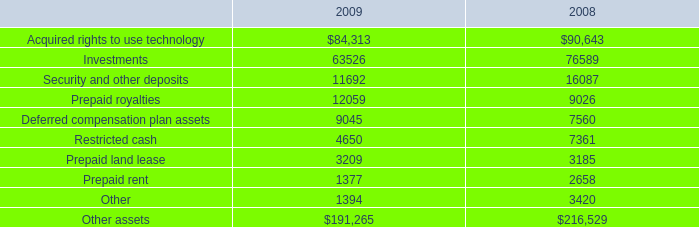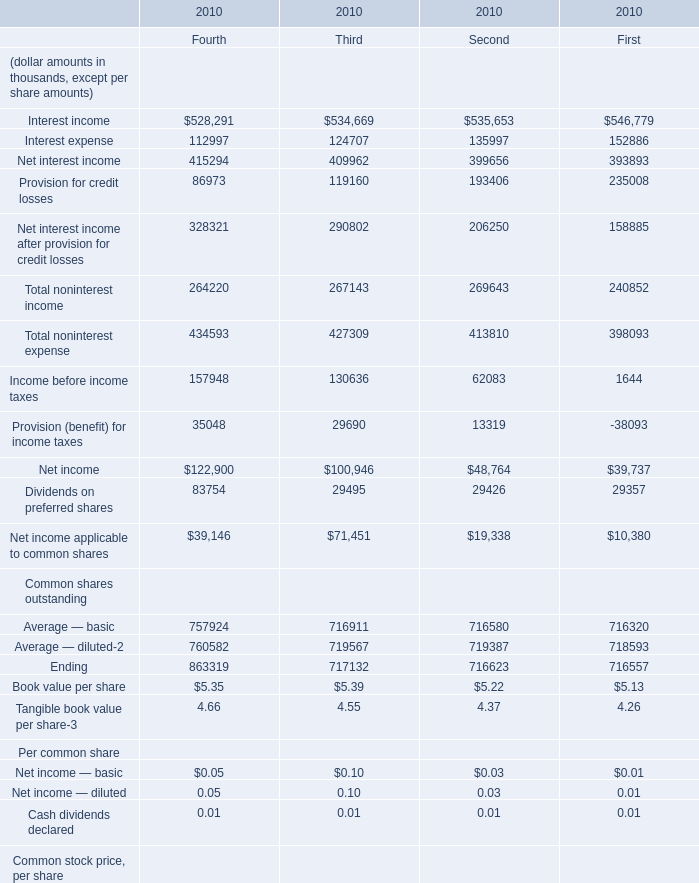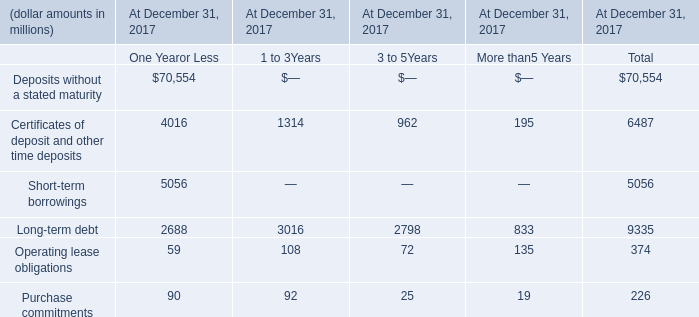What's the current growth rate of Provision for credit losses quarterly? 
Computations: ((86973 - 119160) / 119160)
Answer: -0.27012. 